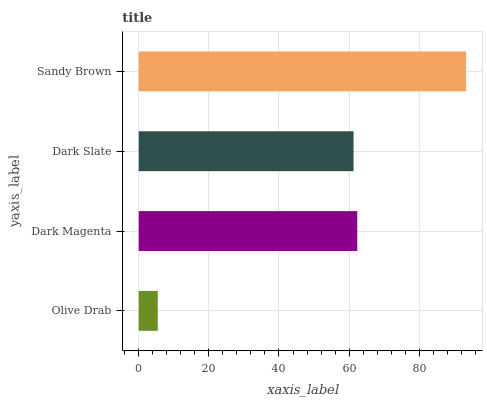Is Olive Drab the minimum?
Answer yes or no. Yes. Is Sandy Brown the maximum?
Answer yes or no. Yes. Is Dark Magenta the minimum?
Answer yes or no. No. Is Dark Magenta the maximum?
Answer yes or no. No. Is Dark Magenta greater than Olive Drab?
Answer yes or no. Yes. Is Olive Drab less than Dark Magenta?
Answer yes or no. Yes. Is Olive Drab greater than Dark Magenta?
Answer yes or no. No. Is Dark Magenta less than Olive Drab?
Answer yes or no. No. Is Dark Magenta the high median?
Answer yes or no. Yes. Is Dark Slate the low median?
Answer yes or no. Yes. Is Sandy Brown the high median?
Answer yes or no. No. Is Sandy Brown the low median?
Answer yes or no. No. 